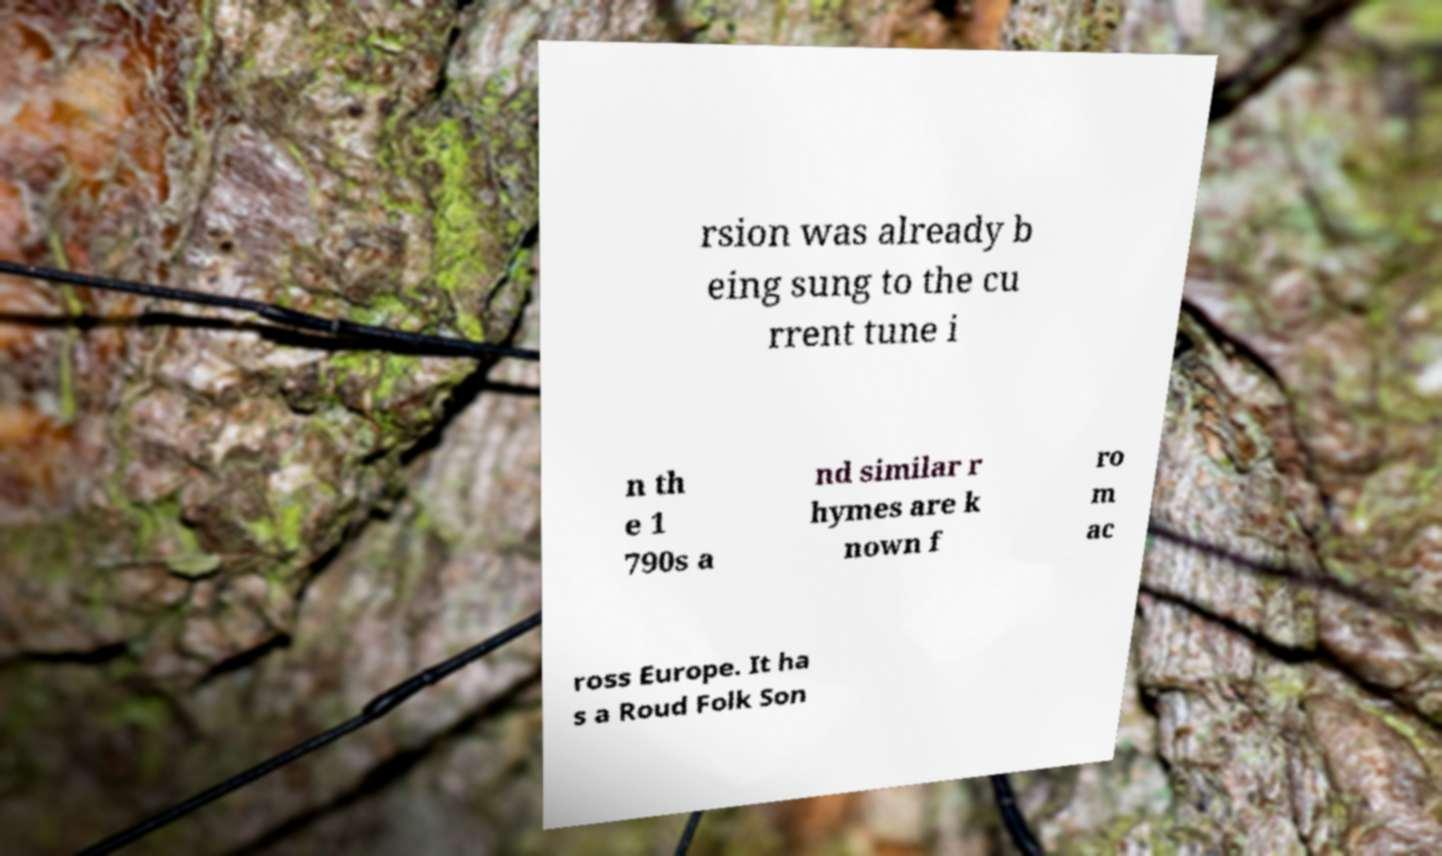Please identify and transcribe the text found in this image. rsion was already b eing sung to the cu rrent tune i n th e 1 790s a nd similar r hymes are k nown f ro m ac ross Europe. It ha s a Roud Folk Son 